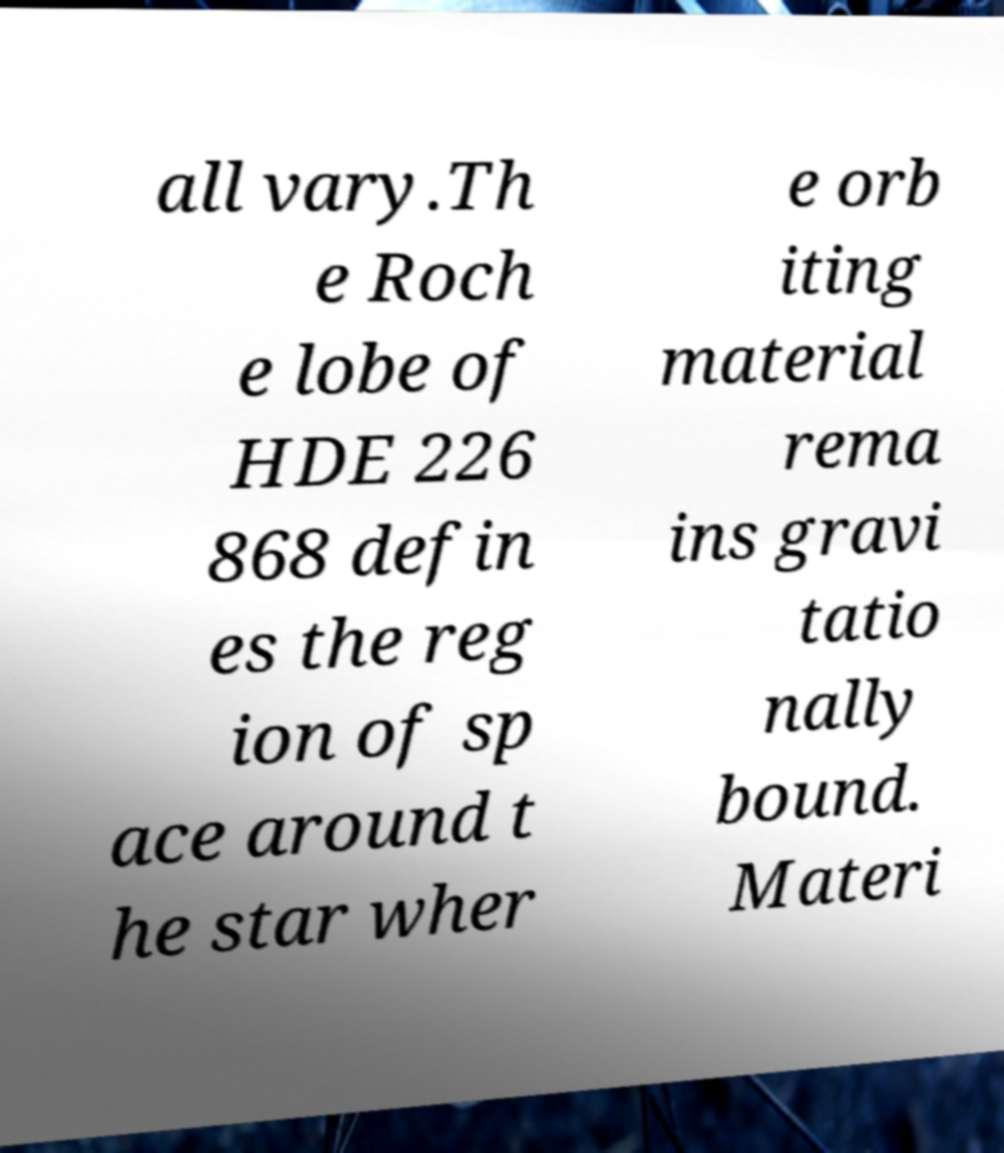Can you accurately transcribe the text from the provided image for me? all vary.Th e Roch e lobe of HDE 226 868 defin es the reg ion of sp ace around t he star wher e orb iting material rema ins gravi tatio nally bound. Materi 